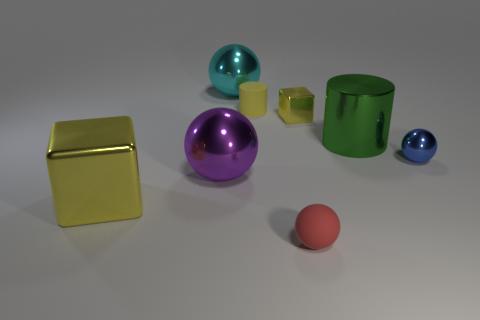What is the shape of the small object that is the same color as the tiny rubber cylinder?
Your answer should be very brief. Cube. How many other things are the same color as the tiny shiny block?
Give a very brief answer. 2. The other cube that is the same color as the small cube is what size?
Provide a short and direct response. Large. Does the tiny cube have the same color as the tiny matte cylinder?
Keep it short and to the point. Yes. What is the shape of the purple shiny thing?
Provide a succinct answer. Sphere. Is there a shiny object that has the same color as the tiny metallic cube?
Keep it short and to the point. Yes. Is the number of metal cubes that are to the left of the rubber ball greater than the number of blue matte cylinders?
Ensure brevity in your answer.  Yes. Do the cyan shiny object and the matte object in front of the small blue thing have the same shape?
Make the answer very short. Yes. Is there a tiny rubber object?
Your response must be concise. Yes. How many big things are either shiny cylinders or metallic blocks?
Give a very brief answer. 2. 